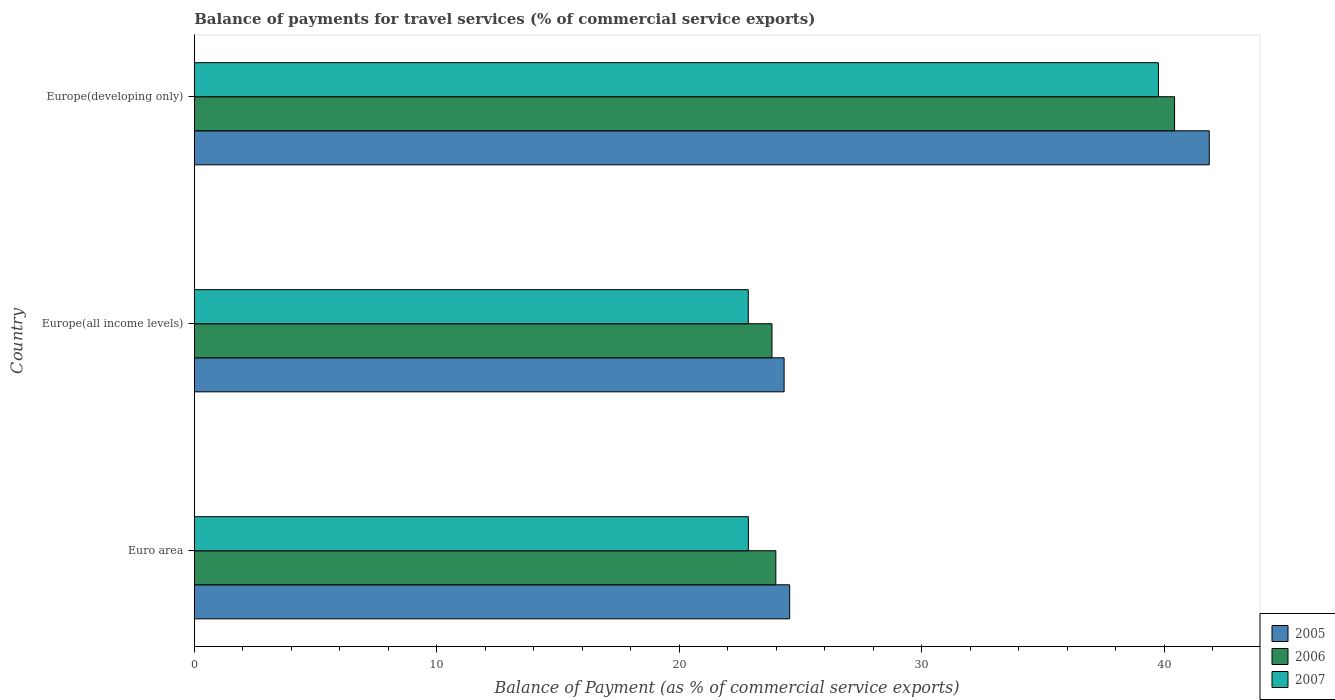How many different coloured bars are there?
Your response must be concise. 3. How many groups of bars are there?
Offer a terse response. 3. How many bars are there on the 2nd tick from the top?
Offer a terse response. 3. How many bars are there on the 3rd tick from the bottom?
Provide a succinct answer. 3. What is the label of the 1st group of bars from the top?
Make the answer very short. Europe(developing only). What is the balance of payments for travel services in 2006 in Europe(developing only)?
Provide a short and direct response. 40.43. Across all countries, what is the maximum balance of payments for travel services in 2007?
Keep it short and to the point. 39.77. Across all countries, what is the minimum balance of payments for travel services in 2007?
Give a very brief answer. 22.85. In which country was the balance of payments for travel services in 2007 maximum?
Provide a short and direct response. Europe(developing only). In which country was the balance of payments for travel services in 2007 minimum?
Offer a terse response. Europe(all income levels). What is the total balance of payments for travel services in 2005 in the graph?
Give a very brief answer. 90.75. What is the difference between the balance of payments for travel services in 2007 in Europe(all income levels) and that in Europe(developing only)?
Your answer should be very brief. -16.92. What is the difference between the balance of payments for travel services in 2007 in Europe(developing only) and the balance of payments for travel services in 2006 in Europe(all income levels)?
Offer a very short reply. 15.94. What is the average balance of payments for travel services in 2007 per country?
Your answer should be compact. 28.49. What is the difference between the balance of payments for travel services in 2007 and balance of payments for travel services in 2006 in Euro area?
Provide a short and direct response. -1.13. What is the ratio of the balance of payments for travel services in 2007 in Europe(all income levels) to that in Europe(developing only)?
Ensure brevity in your answer.  0.57. Is the balance of payments for travel services in 2006 in Euro area less than that in Europe(developing only)?
Provide a short and direct response. Yes. What is the difference between the highest and the second highest balance of payments for travel services in 2007?
Give a very brief answer. 16.91. What is the difference between the highest and the lowest balance of payments for travel services in 2007?
Provide a short and direct response. 16.92. Is the sum of the balance of payments for travel services in 2005 in Europe(all income levels) and Europe(developing only) greater than the maximum balance of payments for travel services in 2006 across all countries?
Offer a terse response. Yes. What does the 1st bar from the bottom in Europe(developing only) represents?
Provide a short and direct response. 2005. Is it the case that in every country, the sum of the balance of payments for travel services in 2005 and balance of payments for travel services in 2007 is greater than the balance of payments for travel services in 2006?
Provide a short and direct response. Yes. How many bars are there?
Ensure brevity in your answer.  9. Are all the bars in the graph horizontal?
Offer a terse response. Yes. What is the difference between two consecutive major ticks on the X-axis?
Your answer should be compact. 10. Does the graph contain grids?
Offer a very short reply. No. Where does the legend appear in the graph?
Ensure brevity in your answer.  Bottom right. How are the legend labels stacked?
Your answer should be compact. Vertical. What is the title of the graph?
Your response must be concise. Balance of payments for travel services (% of commercial service exports). What is the label or title of the X-axis?
Provide a succinct answer. Balance of Payment (as % of commercial service exports). What is the label or title of the Y-axis?
Your answer should be compact. Country. What is the Balance of Payment (as % of commercial service exports) in 2005 in Euro area?
Offer a very short reply. 24.56. What is the Balance of Payment (as % of commercial service exports) in 2006 in Euro area?
Offer a terse response. 23.99. What is the Balance of Payment (as % of commercial service exports) of 2007 in Euro area?
Your answer should be compact. 22.86. What is the Balance of Payment (as % of commercial service exports) of 2005 in Europe(all income levels)?
Offer a terse response. 24.33. What is the Balance of Payment (as % of commercial service exports) of 2006 in Europe(all income levels)?
Ensure brevity in your answer.  23.83. What is the Balance of Payment (as % of commercial service exports) in 2007 in Europe(all income levels)?
Your answer should be compact. 22.85. What is the Balance of Payment (as % of commercial service exports) of 2005 in Europe(developing only)?
Offer a terse response. 41.87. What is the Balance of Payment (as % of commercial service exports) of 2006 in Europe(developing only)?
Your response must be concise. 40.43. What is the Balance of Payment (as % of commercial service exports) of 2007 in Europe(developing only)?
Offer a terse response. 39.77. Across all countries, what is the maximum Balance of Payment (as % of commercial service exports) in 2005?
Make the answer very short. 41.87. Across all countries, what is the maximum Balance of Payment (as % of commercial service exports) in 2006?
Provide a succinct answer. 40.43. Across all countries, what is the maximum Balance of Payment (as % of commercial service exports) of 2007?
Offer a terse response. 39.77. Across all countries, what is the minimum Balance of Payment (as % of commercial service exports) of 2005?
Your answer should be very brief. 24.33. Across all countries, what is the minimum Balance of Payment (as % of commercial service exports) in 2006?
Give a very brief answer. 23.83. Across all countries, what is the minimum Balance of Payment (as % of commercial service exports) of 2007?
Offer a terse response. 22.85. What is the total Balance of Payment (as % of commercial service exports) of 2005 in the graph?
Your answer should be compact. 90.75. What is the total Balance of Payment (as % of commercial service exports) of 2006 in the graph?
Provide a succinct answer. 88.25. What is the total Balance of Payment (as % of commercial service exports) of 2007 in the graph?
Offer a very short reply. 85.48. What is the difference between the Balance of Payment (as % of commercial service exports) of 2005 in Euro area and that in Europe(all income levels)?
Provide a short and direct response. 0.23. What is the difference between the Balance of Payment (as % of commercial service exports) in 2006 in Euro area and that in Europe(all income levels)?
Your answer should be very brief. 0.16. What is the difference between the Balance of Payment (as % of commercial service exports) in 2007 in Euro area and that in Europe(all income levels)?
Offer a very short reply. 0. What is the difference between the Balance of Payment (as % of commercial service exports) in 2005 in Euro area and that in Europe(developing only)?
Offer a very short reply. -17.31. What is the difference between the Balance of Payment (as % of commercial service exports) of 2006 in Euro area and that in Europe(developing only)?
Give a very brief answer. -16.45. What is the difference between the Balance of Payment (as % of commercial service exports) in 2007 in Euro area and that in Europe(developing only)?
Give a very brief answer. -16.91. What is the difference between the Balance of Payment (as % of commercial service exports) in 2005 in Europe(all income levels) and that in Europe(developing only)?
Offer a very short reply. -17.54. What is the difference between the Balance of Payment (as % of commercial service exports) in 2006 in Europe(all income levels) and that in Europe(developing only)?
Provide a short and direct response. -16.61. What is the difference between the Balance of Payment (as % of commercial service exports) of 2007 in Europe(all income levels) and that in Europe(developing only)?
Offer a very short reply. -16.92. What is the difference between the Balance of Payment (as % of commercial service exports) of 2005 in Euro area and the Balance of Payment (as % of commercial service exports) of 2006 in Europe(all income levels)?
Give a very brief answer. 0.73. What is the difference between the Balance of Payment (as % of commercial service exports) in 2005 in Euro area and the Balance of Payment (as % of commercial service exports) in 2007 in Europe(all income levels)?
Offer a very short reply. 1.71. What is the difference between the Balance of Payment (as % of commercial service exports) of 2006 in Euro area and the Balance of Payment (as % of commercial service exports) of 2007 in Europe(all income levels)?
Your response must be concise. 1.14. What is the difference between the Balance of Payment (as % of commercial service exports) in 2005 in Euro area and the Balance of Payment (as % of commercial service exports) in 2006 in Europe(developing only)?
Give a very brief answer. -15.88. What is the difference between the Balance of Payment (as % of commercial service exports) in 2005 in Euro area and the Balance of Payment (as % of commercial service exports) in 2007 in Europe(developing only)?
Ensure brevity in your answer.  -15.21. What is the difference between the Balance of Payment (as % of commercial service exports) in 2006 in Euro area and the Balance of Payment (as % of commercial service exports) in 2007 in Europe(developing only)?
Your answer should be compact. -15.78. What is the difference between the Balance of Payment (as % of commercial service exports) of 2005 in Europe(all income levels) and the Balance of Payment (as % of commercial service exports) of 2006 in Europe(developing only)?
Your response must be concise. -16.11. What is the difference between the Balance of Payment (as % of commercial service exports) of 2005 in Europe(all income levels) and the Balance of Payment (as % of commercial service exports) of 2007 in Europe(developing only)?
Ensure brevity in your answer.  -15.44. What is the difference between the Balance of Payment (as % of commercial service exports) in 2006 in Europe(all income levels) and the Balance of Payment (as % of commercial service exports) in 2007 in Europe(developing only)?
Offer a terse response. -15.94. What is the average Balance of Payment (as % of commercial service exports) of 2005 per country?
Provide a short and direct response. 30.25. What is the average Balance of Payment (as % of commercial service exports) of 2006 per country?
Make the answer very short. 29.42. What is the average Balance of Payment (as % of commercial service exports) in 2007 per country?
Keep it short and to the point. 28.49. What is the difference between the Balance of Payment (as % of commercial service exports) in 2005 and Balance of Payment (as % of commercial service exports) in 2006 in Euro area?
Your answer should be very brief. 0.57. What is the difference between the Balance of Payment (as % of commercial service exports) of 2005 and Balance of Payment (as % of commercial service exports) of 2007 in Euro area?
Keep it short and to the point. 1.7. What is the difference between the Balance of Payment (as % of commercial service exports) of 2006 and Balance of Payment (as % of commercial service exports) of 2007 in Euro area?
Your response must be concise. 1.13. What is the difference between the Balance of Payment (as % of commercial service exports) in 2005 and Balance of Payment (as % of commercial service exports) in 2006 in Europe(all income levels)?
Provide a succinct answer. 0.5. What is the difference between the Balance of Payment (as % of commercial service exports) of 2005 and Balance of Payment (as % of commercial service exports) of 2007 in Europe(all income levels)?
Provide a succinct answer. 1.48. What is the difference between the Balance of Payment (as % of commercial service exports) in 2006 and Balance of Payment (as % of commercial service exports) in 2007 in Europe(all income levels)?
Your answer should be very brief. 0.98. What is the difference between the Balance of Payment (as % of commercial service exports) in 2005 and Balance of Payment (as % of commercial service exports) in 2006 in Europe(developing only)?
Your response must be concise. 1.43. What is the difference between the Balance of Payment (as % of commercial service exports) of 2005 and Balance of Payment (as % of commercial service exports) of 2007 in Europe(developing only)?
Offer a terse response. 2.1. What is the difference between the Balance of Payment (as % of commercial service exports) of 2006 and Balance of Payment (as % of commercial service exports) of 2007 in Europe(developing only)?
Your response must be concise. 0.67. What is the ratio of the Balance of Payment (as % of commercial service exports) in 2005 in Euro area to that in Europe(all income levels)?
Your answer should be very brief. 1.01. What is the ratio of the Balance of Payment (as % of commercial service exports) in 2006 in Euro area to that in Europe(all income levels)?
Provide a succinct answer. 1.01. What is the ratio of the Balance of Payment (as % of commercial service exports) in 2007 in Euro area to that in Europe(all income levels)?
Provide a succinct answer. 1. What is the ratio of the Balance of Payment (as % of commercial service exports) of 2005 in Euro area to that in Europe(developing only)?
Your answer should be compact. 0.59. What is the ratio of the Balance of Payment (as % of commercial service exports) of 2006 in Euro area to that in Europe(developing only)?
Your answer should be compact. 0.59. What is the ratio of the Balance of Payment (as % of commercial service exports) in 2007 in Euro area to that in Europe(developing only)?
Your response must be concise. 0.57. What is the ratio of the Balance of Payment (as % of commercial service exports) of 2005 in Europe(all income levels) to that in Europe(developing only)?
Your response must be concise. 0.58. What is the ratio of the Balance of Payment (as % of commercial service exports) of 2006 in Europe(all income levels) to that in Europe(developing only)?
Your answer should be compact. 0.59. What is the ratio of the Balance of Payment (as % of commercial service exports) of 2007 in Europe(all income levels) to that in Europe(developing only)?
Provide a succinct answer. 0.57. What is the difference between the highest and the second highest Balance of Payment (as % of commercial service exports) in 2005?
Provide a succinct answer. 17.31. What is the difference between the highest and the second highest Balance of Payment (as % of commercial service exports) in 2006?
Give a very brief answer. 16.45. What is the difference between the highest and the second highest Balance of Payment (as % of commercial service exports) of 2007?
Your response must be concise. 16.91. What is the difference between the highest and the lowest Balance of Payment (as % of commercial service exports) of 2005?
Your answer should be compact. 17.54. What is the difference between the highest and the lowest Balance of Payment (as % of commercial service exports) of 2006?
Provide a succinct answer. 16.61. What is the difference between the highest and the lowest Balance of Payment (as % of commercial service exports) of 2007?
Provide a succinct answer. 16.92. 